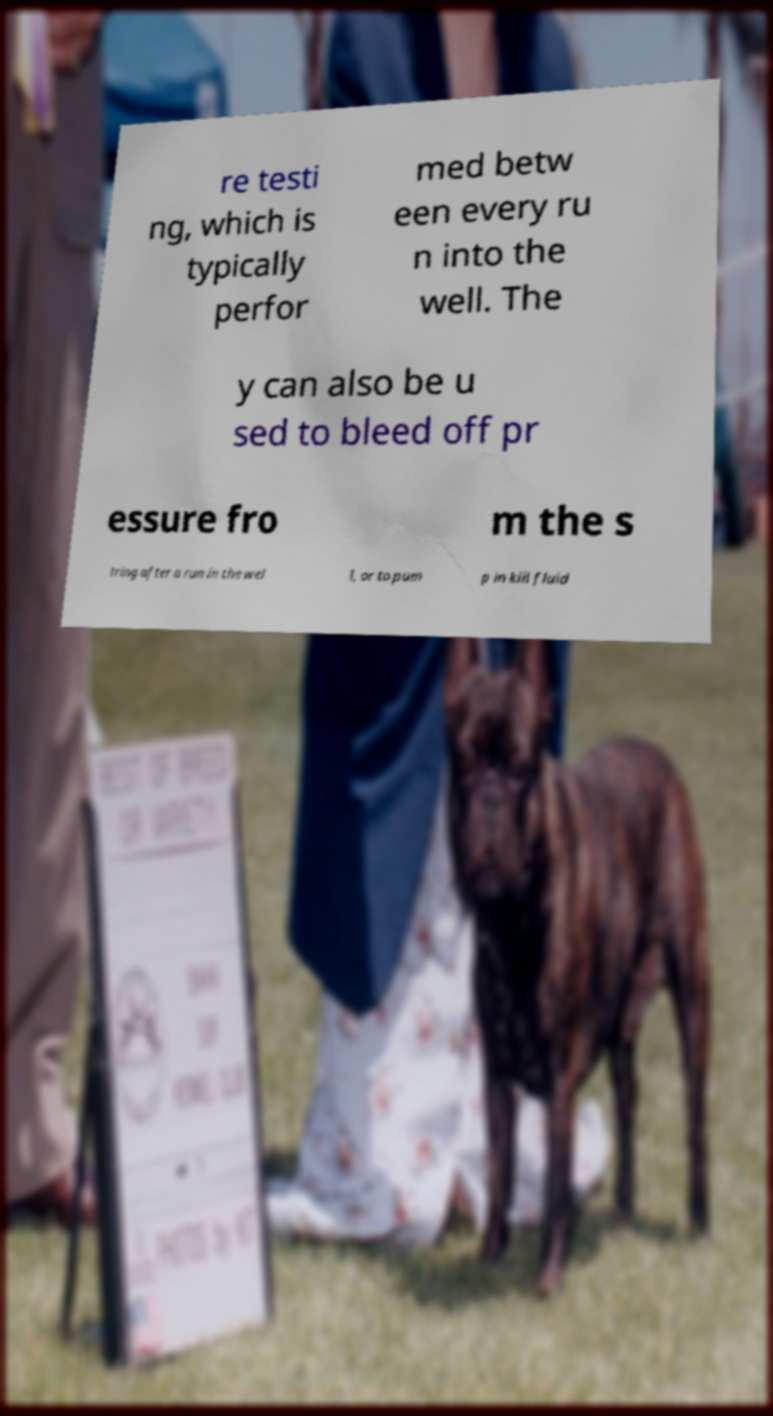Could you assist in decoding the text presented in this image and type it out clearly? re testi ng, which is typically perfor med betw een every ru n into the well. The y can also be u sed to bleed off pr essure fro m the s tring after a run in the wel l, or to pum p in kill fluid 